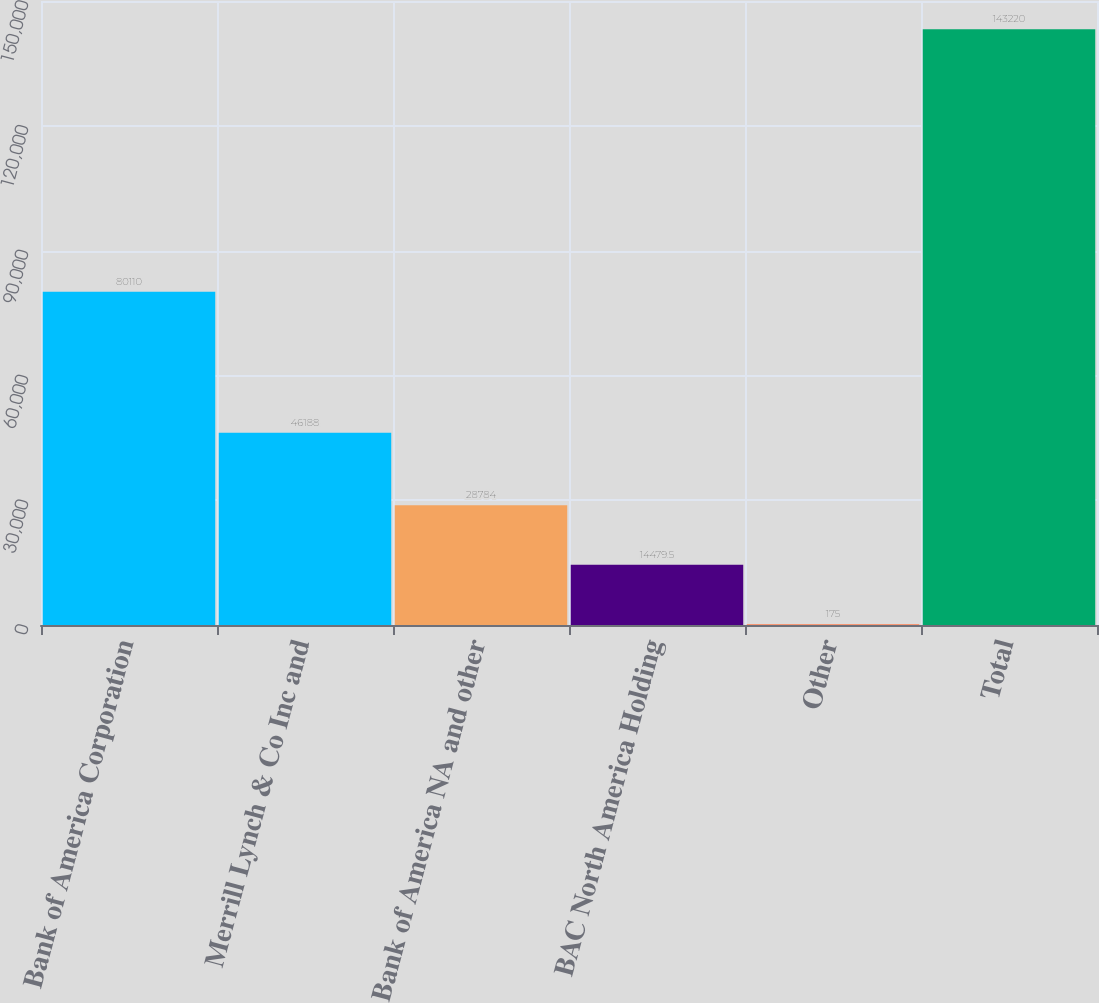<chart> <loc_0><loc_0><loc_500><loc_500><bar_chart><fcel>Bank of America Corporation<fcel>Merrill Lynch & Co Inc and<fcel>Bank of America NA and other<fcel>BAC North America Holding<fcel>Other<fcel>Total<nl><fcel>80110<fcel>46188<fcel>28784<fcel>14479.5<fcel>175<fcel>143220<nl></chart> 